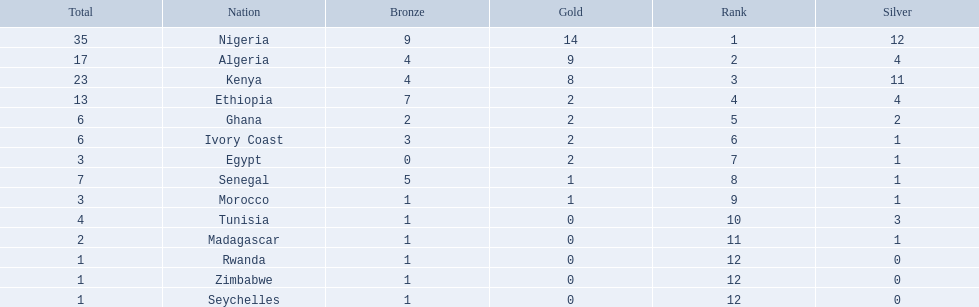Which nations competed in the 1989 african championships in athletics? Nigeria, Algeria, Kenya, Ethiopia, Ghana, Ivory Coast, Egypt, Senegal, Morocco, Tunisia, Madagascar, Rwanda, Zimbabwe, Seychelles. Of these nations, which earned 0 bronze medals? Egypt. 